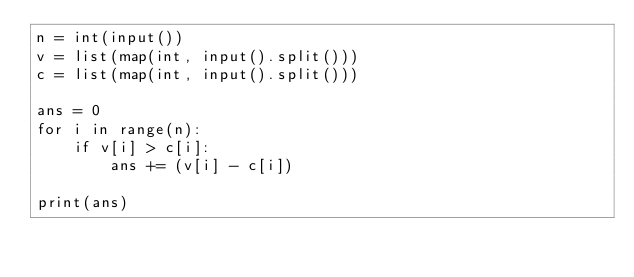Convert code to text. <code><loc_0><loc_0><loc_500><loc_500><_Python_>n = int(input())
v = list(map(int, input().split()))
c = list(map(int, input().split()))

ans = 0
for i in range(n):
    if v[i] > c[i]:
        ans += (v[i] - c[i])

print(ans)</code> 